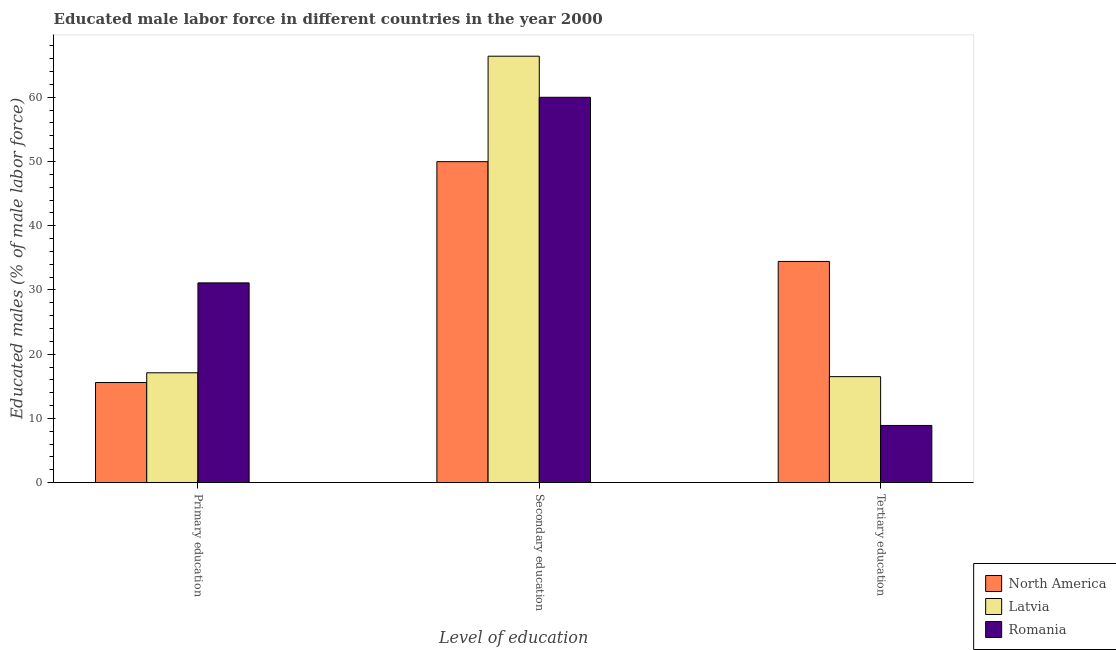Are the number of bars on each tick of the X-axis equal?
Provide a succinct answer. Yes. What is the percentage of male labor force who received secondary education in North America?
Give a very brief answer. 49.98. Across all countries, what is the maximum percentage of male labor force who received primary education?
Your answer should be very brief. 31.1. Across all countries, what is the minimum percentage of male labor force who received primary education?
Keep it short and to the point. 15.59. In which country was the percentage of male labor force who received primary education maximum?
Offer a terse response. Romania. In which country was the percentage of male labor force who received tertiary education minimum?
Offer a very short reply. Romania. What is the total percentage of male labor force who received primary education in the graph?
Your response must be concise. 63.79. What is the difference between the percentage of male labor force who received secondary education in Latvia and that in Romania?
Give a very brief answer. 6.4. What is the difference between the percentage of male labor force who received secondary education in Romania and the percentage of male labor force who received primary education in Latvia?
Offer a very short reply. 42.9. What is the average percentage of male labor force who received tertiary education per country?
Keep it short and to the point. 19.95. What is the difference between the percentage of male labor force who received primary education and percentage of male labor force who received secondary education in Latvia?
Make the answer very short. -49.3. In how many countries, is the percentage of male labor force who received secondary education greater than 18 %?
Your answer should be very brief. 3. What is the ratio of the percentage of male labor force who received tertiary education in North America to that in Romania?
Your answer should be very brief. 3.87. Is the percentage of male labor force who received primary education in North America less than that in Latvia?
Provide a short and direct response. Yes. Is the difference between the percentage of male labor force who received tertiary education in Romania and Latvia greater than the difference between the percentage of male labor force who received secondary education in Romania and Latvia?
Offer a terse response. No. What is the difference between the highest and the second highest percentage of male labor force who received secondary education?
Make the answer very short. 6.4. What is the difference between the highest and the lowest percentage of male labor force who received tertiary education?
Offer a very short reply. 25.54. Is the sum of the percentage of male labor force who received primary education in Latvia and North America greater than the maximum percentage of male labor force who received tertiary education across all countries?
Provide a succinct answer. No. What does the 1st bar from the left in Tertiary education represents?
Give a very brief answer. North America. What does the 2nd bar from the right in Primary education represents?
Make the answer very short. Latvia. Are all the bars in the graph horizontal?
Ensure brevity in your answer.  No. What is the difference between two consecutive major ticks on the Y-axis?
Offer a very short reply. 10. Does the graph contain grids?
Your answer should be compact. No. Where does the legend appear in the graph?
Offer a very short reply. Bottom right. What is the title of the graph?
Your response must be concise. Educated male labor force in different countries in the year 2000. Does "Mozambique" appear as one of the legend labels in the graph?
Keep it short and to the point. No. What is the label or title of the X-axis?
Keep it short and to the point. Level of education. What is the label or title of the Y-axis?
Keep it short and to the point. Educated males (% of male labor force). What is the Educated males (% of male labor force) of North America in Primary education?
Keep it short and to the point. 15.59. What is the Educated males (% of male labor force) of Latvia in Primary education?
Your answer should be very brief. 17.1. What is the Educated males (% of male labor force) of Romania in Primary education?
Provide a succinct answer. 31.1. What is the Educated males (% of male labor force) of North America in Secondary education?
Your answer should be compact. 49.98. What is the Educated males (% of male labor force) of Latvia in Secondary education?
Offer a very short reply. 66.4. What is the Educated males (% of male labor force) in Romania in Secondary education?
Offer a very short reply. 60. What is the Educated males (% of male labor force) of North America in Tertiary education?
Your answer should be compact. 34.44. What is the Educated males (% of male labor force) in Romania in Tertiary education?
Provide a succinct answer. 8.9. Across all Level of education, what is the maximum Educated males (% of male labor force) of North America?
Keep it short and to the point. 49.98. Across all Level of education, what is the maximum Educated males (% of male labor force) in Latvia?
Your answer should be very brief. 66.4. Across all Level of education, what is the minimum Educated males (% of male labor force) in North America?
Keep it short and to the point. 15.59. Across all Level of education, what is the minimum Educated males (% of male labor force) of Latvia?
Your response must be concise. 16.5. Across all Level of education, what is the minimum Educated males (% of male labor force) in Romania?
Your response must be concise. 8.9. What is the total Educated males (% of male labor force) of Latvia in the graph?
Make the answer very short. 100. What is the total Educated males (% of male labor force) of Romania in the graph?
Provide a succinct answer. 100. What is the difference between the Educated males (% of male labor force) of North America in Primary education and that in Secondary education?
Give a very brief answer. -34.39. What is the difference between the Educated males (% of male labor force) of Latvia in Primary education and that in Secondary education?
Your response must be concise. -49.3. What is the difference between the Educated males (% of male labor force) of Romania in Primary education and that in Secondary education?
Give a very brief answer. -28.9. What is the difference between the Educated males (% of male labor force) in North America in Primary education and that in Tertiary education?
Your response must be concise. -18.85. What is the difference between the Educated males (% of male labor force) of Romania in Primary education and that in Tertiary education?
Keep it short and to the point. 22.2. What is the difference between the Educated males (% of male labor force) of North America in Secondary education and that in Tertiary education?
Provide a succinct answer. 15.54. What is the difference between the Educated males (% of male labor force) in Latvia in Secondary education and that in Tertiary education?
Provide a succinct answer. 49.9. What is the difference between the Educated males (% of male labor force) in Romania in Secondary education and that in Tertiary education?
Offer a terse response. 51.1. What is the difference between the Educated males (% of male labor force) of North America in Primary education and the Educated males (% of male labor force) of Latvia in Secondary education?
Ensure brevity in your answer.  -50.81. What is the difference between the Educated males (% of male labor force) of North America in Primary education and the Educated males (% of male labor force) of Romania in Secondary education?
Your response must be concise. -44.41. What is the difference between the Educated males (% of male labor force) of Latvia in Primary education and the Educated males (% of male labor force) of Romania in Secondary education?
Your answer should be very brief. -42.9. What is the difference between the Educated males (% of male labor force) in North America in Primary education and the Educated males (% of male labor force) in Latvia in Tertiary education?
Offer a very short reply. -0.91. What is the difference between the Educated males (% of male labor force) in North America in Primary education and the Educated males (% of male labor force) in Romania in Tertiary education?
Ensure brevity in your answer.  6.69. What is the difference between the Educated males (% of male labor force) in Latvia in Primary education and the Educated males (% of male labor force) in Romania in Tertiary education?
Your answer should be very brief. 8.2. What is the difference between the Educated males (% of male labor force) of North America in Secondary education and the Educated males (% of male labor force) of Latvia in Tertiary education?
Ensure brevity in your answer.  33.48. What is the difference between the Educated males (% of male labor force) of North America in Secondary education and the Educated males (% of male labor force) of Romania in Tertiary education?
Offer a very short reply. 41.08. What is the difference between the Educated males (% of male labor force) in Latvia in Secondary education and the Educated males (% of male labor force) in Romania in Tertiary education?
Provide a short and direct response. 57.5. What is the average Educated males (% of male labor force) of North America per Level of education?
Your response must be concise. 33.33. What is the average Educated males (% of male labor force) in Latvia per Level of education?
Your answer should be compact. 33.33. What is the average Educated males (% of male labor force) of Romania per Level of education?
Keep it short and to the point. 33.33. What is the difference between the Educated males (% of male labor force) of North America and Educated males (% of male labor force) of Latvia in Primary education?
Give a very brief answer. -1.51. What is the difference between the Educated males (% of male labor force) of North America and Educated males (% of male labor force) of Romania in Primary education?
Make the answer very short. -15.51. What is the difference between the Educated males (% of male labor force) of North America and Educated males (% of male labor force) of Latvia in Secondary education?
Provide a short and direct response. -16.42. What is the difference between the Educated males (% of male labor force) of North America and Educated males (% of male labor force) of Romania in Secondary education?
Provide a short and direct response. -10.02. What is the difference between the Educated males (% of male labor force) of Latvia and Educated males (% of male labor force) of Romania in Secondary education?
Your answer should be very brief. 6.4. What is the difference between the Educated males (% of male labor force) of North America and Educated males (% of male labor force) of Latvia in Tertiary education?
Offer a very short reply. 17.94. What is the difference between the Educated males (% of male labor force) of North America and Educated males (% of male labor force) of Romania in Tertiary education?
Keep it short and to the point. 25.54. What is the ratio of the Educated males (% of male labor force) of North America in Primary education to that in Secondary education?
Give a very brief answer. 0.31. What is the ratio of the Educated males (% of male labor force) of Latvia in Primary education to that in Secondary education?
Your response must be concise. 0.26. What is the ratio of the Educated males (% of male labor force) in Romania in Primary education to that in Secondary education?
Your response must be concise. 0.52. What is the ratio of the Educated males (% of male labor force) of North America in Primary education to that in Tertiary education?
Offer a very short reply. 0.45. What is the ratio of the Educated males (% of male labor force) of Latvia in Primary education to that in Tertiary education?
Ensure brevity in your answer.  1.04. What is the ratio of the Educated males (% of male labor force) of Romania in Primary education to that in Tertiary education?
Give a very brief answer. 3.49. What is the ratio of the Educated males (% of male labor force) in North America in Secondary education to that in Tertiary education?
Offer a terse response. 1.45. What is the ratio of the Educated males (% of male labor force) of Latvia in Secondary education to that in Tertiary education?
Give a very brief answer. 4.02. What is the ratio of the Educated males (% of male labor force) in Romania in Secondary education to that in Tertiary education?
Offer a terse response. 6.74. What is the difference between the highest and the second highest Educated males (% of male labor force) in North America?
Offer a terse response. 15.54. What is the difference between the highest and the second highest Educated males (% of male labor force) in Latvia?
Provide a succinct answer. 49.3. What is the difference between the highest and the second highest Educated males (% of male labor force) of Romania?
Provide a short and direct response. 28.9. What is the difference between the highest and the lowest Educated males (% of male labor force) of North America?
Ensure brevity in your answer.  34.39. What is the difference between the highest and the lowest Educated males (% of male labor force) in Latvia?
Make the answer very short. 49.9. What is the difference between the highest and the lowest Educated males (% of male labor force) in Romania?
Provide a succinct answer. 51.1. 